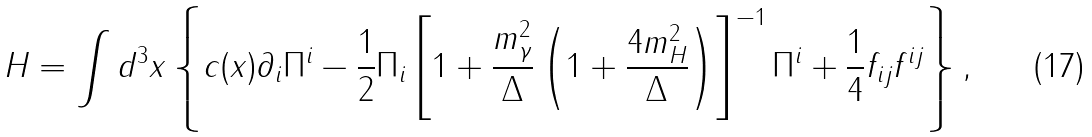Convert formula to latex. <formula><loc_0><loc_0><loc_500><loc_500>H = \int { d ^ { 3 } x } \left \{ { c ( x ) \partial _ { i } \Pi ^ { i } - \frac { 1 } { 2 } \Pi _ { i } \left [ { 1 + \frac { m _ { \gamma } ^ { 2 } } { \Delta } \left ( { 1 + \frac { 4 m _ { H } ^ { 2 } } { \Delta } } \right ) } \right ] ^ { - 1 } \Pi ^ { i } + \frac { 1 } { 4 } f _ { i j } f ^ { i j } } \right \} ,</formula> 